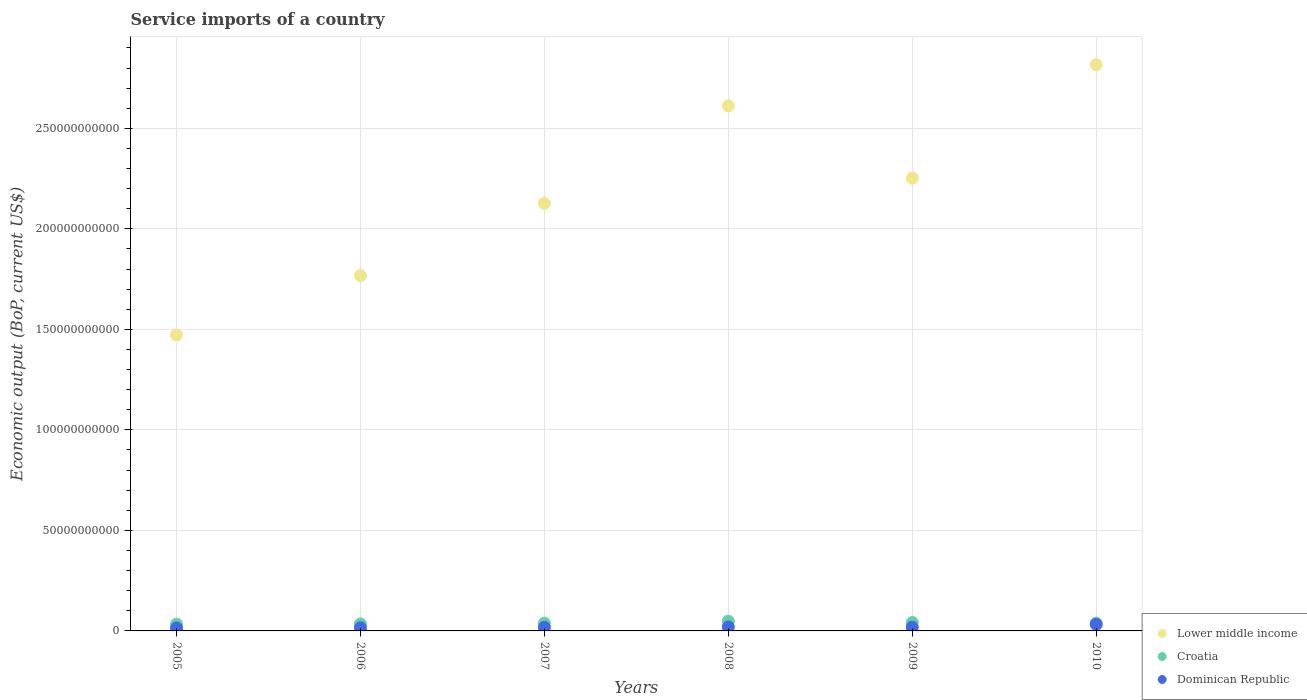How many different coloured dotlines are there?
Provide a succinct answer. 3. Is the number of dotlines equal to the number of legend labels?
Provide a succinct answer. Yes. What is the service imports in Lower middle income in 2007?
Provide a succinct answer. 2.13e+11. Across all years, what is the maximum service imports in Dominican Republic?
Your response must be concise. 3.29e+09. Across all years, what is the minimum service imports in Lower middle income?
Offer a very short reply. 1.47e+11. In which year was the service imports in Dominican Republic maximum?
Make the answer very short. 2010. What is the total service imports in Lower middle income in the graph?
Keep it short and to the point. 1.30e+12. What is the difference between the service imports in Dominican Republic in 2006 and that in 2008?
Offer a terse response. -4.07e+08. What is the difference between the service imports in Dominican Republic in 2007 and the service imports in Croatia in 2009?
Your answer should be very brief. -2.41e+09. What is the average service imports in Croatia per year?
Give a very brief answer. 3.93e+09. In the year 2005, what is the difference between the service imports in Dominican Republic and service imports in Lower middle income?
Your response must be concise. -1.46e+11. In how many years, is the service imports in Croatia greater than 90000000000 US$?
Make the answer very short. 0. What is the ratio of the service imports in Lower middle income in 2005 to that in 2009?
Offer a terse response. 0.65. Is the service imports in Dominican Republic in 2008 less than that in 2009?
Offer a terse response. No. Is the difference between the service imports in Dominican Republic in 2006 and 2010 greater than the difference between the service imports in Lower middle income in 2006 and 2010?
Provide a succinct answer. Yes. What is the difference between the highest and the second highest service imports in Dominican Republic?
Ensure brevity in your answer.  1.30e+09. What is the difference between the highest and the lowest service imports in Croatia?
Offer a very short reply. 1.46e+09. In how many years, is the service imports in Lower middle income greater than the average service imports in Lower middle income taken over all years?
Ensure brevity in your answer.  3. Does the service imports in Dominican Republic monotonically increase over the years?
Ensure brevity in your answer.  No. Is the service imports in Dominican Republic strictly greater than the service imports in Croatia over the years?
Make the answer very short. No. Is the service imports in Lower middle income strictly less than the service imports in Croatia over the years?
Your answer should be very brief. No. How many dotlines are there?
Provide a succinct answer. 3. How many years are there in the graph?
Make the answer very short. 6. What is the difference between two consecutive major ticks on the Y-axis?
Give a very brief answer. 5.00e+1. Are the values on the major ticks of Y-axis written in scientific E-notation?
Your answer should be very brief. No. Does the graph contain grids?
Offer a terse response. Yes. Where does the legend appear in the graph?
Keep it short and to the point. Bottom right. How many legend labels are there?
Give a very brief answer. 3. How are the legend labels stacked?
Your answer should be very brief. Vertical. What is the title of the graph?
Provide a succinct answer. Service imports of a country. Does "Libya" appear as one of the legend labels in the graph?
Your answer should be compact. No. What is the label or title of the Y-axis?
Provide a succinct answer. Economic output (BoP, current US$). What is the Economic output (BoP, current US$) of Lower middle income in 2005?
Ensure brevity in your answer.  1.47e+11. What is the Economic output (BoP, current US$) in Croatia in 2005?
Make the answer very short. 3.37e+09. What is the Economic output (BoP, current US$) of Dominican Republic in 2005?
Your answer should be very brief. 1.48e+09. What is the Economic output (BoP, current US$) of Lower middle income in 2006?
Offer a very short reply. 1.77e+11. What is the Economic output (BoP, current US$) of Croatia in 2006?
Offer a very short reply. 3.51e+09. What is the Economic output (BoP, current US$) of Dominican Republic in 2006?
Ensure brevity in your answer.  1.58e+09. What is the Economic output (BoP, current US$) of Lower middle income in 2007?
Provide a succinct answer. 2.13e+11. What is the Economic output (BoP, current US$) of Croatia in 2007?
Offer a terse response. 3.84e+09. What is the Economic output (BoP, current US$) in Dominican Republic in 2007?
Offer a very short reply. 1.77e+09. What is the Economic output (BoP, current US$) of Lower middle income in 2008?
Offer a terse response. 2.61e+11. What is the Economic output (BoP, current US$) in Croatia in 2008?
Ensure brevity in your answer.  4.83e+09. What is the Economic output (BoP, current US$) in Dominican Republic in 2008?
Make the answer very short. 1.99e+09. What is the Economic output (BoP, current US$) of Lower middle income in 2009?
Give a very brief answer. 2.25e+11. What is the Economic output (BoP, current US$) of Croatia in 2009?
Provide a short and direct response. 4.18e+09. What is the Economic output (BoP, current US$) in Dominican Republic in 2009?
Make the answer very short. 1.86e+09. What is the Economic output (BoP, current US$) in Lower middle income in 2010?
Ensure brevity in your answer.  2.82e+11. What is the Economic output (BoP, current US$) in Croatia in 2010?
Offer a terse response. 3.86e+09. What is the Economic output (BoP, current US$) in Dominican Republic in 2010?
Offer a terse response. 3.29e+09. Across all years, what is the maximum Economic output (BoP, current US$) of Lower middle income?
Your response must be concise. 2.82e+11. Across all years, what is the maximum Economic output (BoP, current US$) in Croatia?
Keep it short and to the point. 4.83e+09. Across all years, what is the maximum Economic output (BoP, current US$) in Dominican Republic?
Your response must be concise. 3.29e+09. Across all years, what is the minimum Economic output (BoP, current US$) in Lower middle income?
Your answer should be compact. 1.47e+11. Across all years, what is the minimum Economic output (BoP, current US$) in Croatia?
Your response must be concise. 3.37e+09. Across all years, what is the minimum Economic output (BoP, current US$) of Dominican Republic?
Offer a terse response. 1.48e+09. What is the total Economic output (BoP, current US$) in Lower middle income in the graph?
Provide a short and direct response. 1.30e+12. What is the total Economic output (BoP, current US$) of Croatia in the graph?
Your answer should be very brief. 2.36e+1. What is the total Economic output (BoP, current US$) of Dominican Republic in the graph?
Your answer should be compact. 1.20e+1. What is the difference between the Economic output (BoP, current US$) of Lower middle income in 2005 and that in 2006?
Your answer should be very brief. -2.95e+1. What is the difference between the Economic output (BoP, current US$) of Croatia in 2005 and that in 2006?
Your answer should be very brief. -1.38e+08. What is the difference between the Economic output (BoP, current US$) of Dominican Republic in 2005 and that in 2006?
Ensure brevity in your answer.  -1.04e+08. What is the difference between the Economic output (BoP, current US$) in Lower middle income in 2005 and that in 2007?
Provide a short and direct response. -6.55e+1. What is the difference between the Economic output (BoP, current US$) in Croatia in 2005 and that in 2007?
Give a very brief answer. -4.76e+08. What is the difference between the Economic output (BoP, current US$) in Dominican Republic in 2005 and that in 2007?
Give a very brief answer. -2.94e+08. What is the difference between the Economic output (BoP, current US$) in Lower middle income in 2005 and that in 2008?
Provide a succinct answer. -1.14e+11. What is the difference between the Economic output (BoP, current US$) of Croatia in 2005 and that in 2008?
Your answer should be very brief. -1.46e+09. What is the difference between the Economic output (BoP, current US$) of Dominican Republic in 2005 and that in 2008?
Your answer should be very brief. -5.11e+08. What is the difference between the Economic output (BoP, current US$) of Lower middle income in 2005 and that in 2009?
Give a very brief answer. -7.81e+1. What is the difference between the Economic output (BoP, current US$) in Croatia in 2005 and that in 2009?
Keep it short and to the point. -8.15e+08. What is the difference between the Economic output (BoP, current US$) of Dominican Republic in 2005 and that in 2009?
Your answer should be very brief. -3.79e+08. What is the difference between the Economic output (BoP, current US$) in Lower middle income in 2005 and that in 2010?
Offer a terse response. -1.34e+11. What is the difference between the Economic output (BoP, current US$) of Croatia in 2005 and that in 2010?
Provide a succinct answer. -4.94e+08. What is the difference between the Economic output (BoP, current US$) of Dominican Republic in 2005 and that in 2010?
Offer a very short reply. -1.81e+09. What is the difference between the Economic output (BoP, current US$) of Lower middle income in 2006 and that in 2007?
Keep it short and to the point. -3.59e+1. What is the difference between the Economic output (BoP, current US$) in Croatia in 2006 and that in 2007?
Provide a succinct answer. -3.38e+08. What is the difference between the Economic output (BoP, current US$) of Dominican Republic in 2006 and that in 2007?
Provide a short and direct response. -1.90e+08. What is the difference between the Economic output (BoP, current US$) of Lower middle income in 2006 and that in 2008?
Make the answer very short. -8.44e+1. What is the difference between the Economic output (BoP, current US$) in Croatia in 2006 and that in 2008?
Make the answer very short. -1.32e+09. What is the difference between the Economic output (BoP, current US$) in Dominican Republic in 2006 and that in 2008?
Your response must be concise. -4.07e+08. What is the difference between the Economic output (BoP, current US$) in Lower middle income in 2006 and that in 2009?
Offer a terse response. -4.85e+1. What is the difference between the Economic output (BoP, current US$) of Croatia in 2006 and that in 2009?
Your answer should be very brief. -6.77e+08. What is the difference between the Economic output (BoP, current US$) of Dominican Republic in 2006 and that in 2009?
Give a very brief answer. -2.75e+08. What is the difference between the Economic output (BoP, current US$) in Lower middle income in 2006 and that in 2010?
Offer a terse response. -1.05e+11. What is the difference between the Economic output (BoP, current US$) in Croatia in 2006 and that in 2010?
Your answer should be compact. -3.56e+08. What is the difference between the Economic output (BoP, current US$) in Dominican Republic in 2006 and that in 2010?
Provide a short and direct response. -1.70e+09. What is the difference between the Economic output (BoP, current US$) of Lower middle income in 2007 and that in 2008?
Your response must be concise. -4.85e+1. What is the difference between the Economic output (BoP, current US$) of Croatia in 2007 and that in 2008?
Provide a short and direct response. -9.87e+08. What is the difference between the Economic output (BoP, current US$) in Dominican Republic in 2007 and that in 2008?
Provide a short and direct response. -2.17e+08. What is the difference between the Economic output (BoP, current US$) in Lower middle income in 2007 and that in 2009?
Provide a succinct answer. -1.26e+1. What is the difference between the Economic output (BoP, current US$) of Croatia in 2007 and that in 2009?
Provide a short and direct response. -3.39e+08. What is the difference between the Economic output (BoP, current US$) of Dominican Republic in 2007 and that in 2009?
Give a very brief answer. -8.46e+07. What is the difference between the Economic output (BoP, current US$) of Lower middle income in 2007 and that in 2010?
Your answer should be compact. -6.90e+1. What is the difference between the Economic output (BoP, current US$) in Croatia in 2007 and that in 2010?
Provide a short and direct response. -1.77e+07. What is the difference between the Economic output (BoP, current US$) of Dominican Republic in 2007 and that in 2010?
Provide a succinct answer. -1.51e+09. What is the difference between the Economic output (BoP, current US$) in Lower middle income in 2008 and that in 2009?
Your answer should be very brief. 3.59e+1. What is the difference between the Economic output (BoP, current US$) in Croatia in 2008 and that in 2009?
Keep it short and to the point. 6.48e+08. What is the difference between the Economic output (BoP, current US$) in Dominican Republic in 2008 and that in 2009?
Give a very brief answer. 1.32e+08. What is the difference between the Economic output (BoP, current US$) of Lower middle income in 2008 and that in 2010?
Your answer should be compact. -2.05e+1. What is the difference between the Economic output (BoP, current US$) in Croatia in 2008 and that in 2010?
Your answer should be very brief. 9.69e+08. What is the difference between the Economic output (BoP, current US$) in Dominican Republic in 2008 and that in 2010?
Your answer should be very brief. -1.30e+09. What is the difference between the Economic output (BoP, current US$) of Lower middle income in 2009 and that in 2010?
Offer a very short reply. -5.64e+1. What is the difference between the Economic output (BoP, current US$) of Croatia in 2009 and that in 2010?
Offer a very short reply. 3.21e+08. What is the difference between the Economic output (BoP, current US$) in Dominican Republic in 2009 and that in 2010?
Provide a short and direct response. -1.43e+09. What is the difference between the Economic output (BoP, current US$) in Lower middle income in 2005 and the Economic output (BoP, current US$) in Croatia in 2006?
Offer a very short reply. 1.44e+11. What is the difference between the Economic output (BoP, current US$) of Lower middle income in 2005 and the Economic output (BoP, current US$) of Dominican Republic in 2006?
Give a very brief answer. 1.46e+11. What is the difference between the Economic output (BoP, current US$) in Croatia in 2005 and the Economic output (BoP, current US$) in Dominican Republic in 2006?
Make the answer very short. 1.79e+09. What is the difference between the Economic output (BoP, current US$) of Lower middle income in 2005 and the Economic output (BoP, current US$) of Croatia in 2007?
Your response must be concise. 1.43e+11. What is the difference between the Economic output (BoP, current US$) of Lower middle income in 2005 and the Economic output (BoP, current US$) of Dominican Republic in 2007?
Offer a terse response. 1.45e+11. What is the difference between the Economic output (BoP, current US$) in Croatia in 2005 and the Economic output (BoP, current US$) in Dominican Republic in 2007?
Provide a short and direct response. 1.60e+09. What is the difference between the Economic output (BoP, current US$) of Lower middle income in 2005 and the Economic output (BoP, current US$) of Croatia in 2008?
Ensure brevity in your answer.  1.42e+11. What is the difference between the Economic output (BoP, current US$) in Lower middle income in 2005 and the Economic output (BoP, current US$) in Dominican Republic in 2008?
Provide a short and direct response. 1.45e+11. What is the difference between the Economic output (BoP, current US$) in Croatia in 2005 and the Economic output (BoP, current US$) in Dominican Republic in 2008?
Make the answer very short. 1.38e+09. What is the difference between the Economic output (BoP, current US$) of Lower middle income in 2005 and the Economic output (BoP, current US$) of Croatia in 2009?
Ensure brevity in your answer.  1.43e+11. What is the difference between the Economic output (BoP, current US$) of Lower middle income in 2005 and the Economic output (BoP, current US$) of Dominican Republic in 2009?
Provide a succinct answer. 1.45e+11. What is the difference between the Economic output (BoP, current US$) of Croatia in 2005 and the Economic output (BoP, current US$) of Dominican Republic in 2009?
Offer a very short reply. 1.51e+09. What is the difference between the Economic output (BoP, current US$) of Lower middle income in 2005 and the Economic output (BoP, current US$) of Croatia in 2010?
Your answer should be very brief. 1.43e+11. What is the difference between the Economic output (BoP, current US$) of Lower middle income in 2005 and the Economic output (BoP, current US$) of Dominican Republic in 2010?
Your response must be concise. 1.44e+11. What is the difference between the Economic output (BoP, current US$) in Croatia in 2005 and the Economic output (BoP, current US$) in Dominican Republic in 2010?
Offer a very short reply. 8.13e+07. What is the difference between the Economic output (BoP, current US$) in Lower middle income in 2006 and the Economic output (BoP, current US$) in Croatia in 2007?
Keep it short and to the point. 1.73e+11. What is the difference between the Economic output (BoP, current US$) in Lower middle income in 2006 and the Economic output (BoP, current US$) in Dominican Republic in 2007?
Ensure brevity in your answer.  1.75e+11. What is the difference between the Economic output (BoP, current US$) in Croatia in 2006 and the Economic output (BoP, current US$) in Dominican Republic in 2007?
Keep it short and to the point. 1.73e+09. What is the difference between the Economic output (BoP, current US$) in Lower middle income in 2006 and the Economic output (BoP, current US$) in Croatia in 2008?
Offer a very short reply. 1.72e+11. What is the difference between the Economic output (BoP, current US$) of Lower middle income in 2006 and the Economic output (BoP, current US$) of Dominican Republic in 2008?
Your response must be concise. 1.75e+11. What is the difference between the Economic output (BoP, current US$) in Croatia in 2006 and the Economic output (BoP, current US$) in Dominican Republic in 2008?
Provide a succinct answer. 1.52e+09. What is the difference between the Economic output (BoP, current US$) of Lower middle income in 2006 and the Economic output (BoP, current US$) of Croatia in 2009?
Offer a terse response. 1.73e+11. What is the difference between the Economic output (BoP, current US$) of Lower middle income in 2006 and the Economic output (BoP, current US$) of Dominican Republic in 2009?
Keep it short and to the point. 1.75e+11. What is the difference between the Economic output (BoP, current US$) in Croatia in 2006 and the Economic output (BoP, current US$) in Dominican Republic in 2009?
Your response must be concise. 1.65e+09. What is the difference between the Economic output (BoP, current US$) in Lower middle income in 2006 and the Economic output (BoP, current US$) in Croatia in 2010?
Offer a terse response. 1.73e+11. What is the difference between the Economic output (BoP, current US$) of Lower middle income in 2006 and the Economic output (BoP, current US$) of Dominican Republic in 2010?
Provide a succinct answer. 1.73e+11. What is the difference between the Economic output (BoP, current US$) in Croatia in 2006 and the Economic output (BoP, current US$) in Dominican Republic in 2010?
Provide a short and direct response. 2.19e+08. What is the difference between the Economic output (BoP, current US$) in Lower middle income in 2007 and the Economic output (BoP, current US$) in Croatia in 2008?
Provide a short and direct response. 2.08e+11. What is the difference between the Economic output (BoP, current US$) in Lower middle income in 2007 and the Economic output (BoP, current US$) in Dominican Republic in 2008?
Your response must be concise. 2.11e+11. What is the difference between the Economic output (BoP, current US$) of Croatia in 2007 and the Economic output (BoP, current US$) of Dominican Republic in 2008?
Provide a succinct answer. 1.85e+09. What is the difference between the Economic output (BoP, current US$) of Lower middle income in 2007 and the Economic output (BoP, current US$) of Croatia in 2009?
Provide a succinct answer. 2.08e+11. What is the difference between the Economic output (BoP, current US$) in Lower middle income in 2007 and the Economic output (BoP, current US$) in Dominican Republic in 2009?
Offer a terse response. 2.11e+11. What is the difference between the Economic output (BoP, current US$) in Croatia in 2007 and the Economic output (BoP, current US$) in Dominican Republic in 2009?
Keep it short and to the point. 1.99e+09. What is the difference between the Economic output (BoP, current US$) of Lower middle income in 2007 and the Economic output (BoP, current US$) of Croatia in 2010?
Your answer should be very brief. 2.09e+11. What is the difference between the Economic output (BoP, current US$) of Lower middle income in 2007 and the Economic output (BoP, current US$) of Dominican Republic in 2010?
Your answer should be compact. 2.09e+11. What is the difference between the Economic output (BoP, current US$) in Croatia in 2007 and the Economic output (BoP, current US$) in Dominican Republic in 2010?
Provide a succinct answer. 5.57e+08. What is the difference between the Economic output (BoP, current US$) of Lower middle income in 2008 and the Economic output (BoP, current US$) of Croatia in 2009?
Give a very brief answer. 2.57e+11. What is the difference between the Economic output (BoP, current US$) in Lower middle income in 2008 and the Economic output (BoP, current US$) in Dominican Republic in 2009?
Keep it short and to the point. 2.59e+11. What is the difference between the Economic output (BoP, current US$) in Croatia in 2008 and the Economic output (BoP, current US$) in Dominican Republic in 2009?
Offer a very short reply. 2.97e+09. What is the difference between the Economic output (BoP, current US$) of Lower middle income in 2008 and the Economic output (BoP, current US$) of Croatia in 2010?
Ensure brevity in your answer.  2.57e+11. What is the difference between the Economic output (BoP, current US$) in Lower middle income in 2008 and the Economic output (BoP, current US$) in Dominican Republic in 2010?
Offer a very short reply. 2.58e+11. What is the difference between the Economic output (BoP, current US$) of Croatia in 2008 and the Economic output (BoP, current US$) of Dominican Republic in 2010?
Ensure brevity in your answer.  1.54e+09. What is the difference between the Economic output (BoP, current US$) of Lower middle income in 2009 and the Economic output (BoP, current US$) of Croatia in 2010?
Make the answer very short. 2.21e+11. What is the difference between the Economic output (BoP, current US$) of Lower middle income in 2009 and the Economic output (BoP, current US$) of Dominican Republic in 2010?
Your answer should be compact. 2.22e+11. What is the difference between the Economic output (BoP, current US$) in Croatia in 2009 and the Economic output (BoP, current US$) in Dominican Republic in 2010?
Your answer should be very brief. 8.96e+08. What is the average Economic output (BoP, current US$) of Lower middle income per year?
Make the answer very short. 2.17e+11. What is the average Economic output (BoP, current US$) of Croatia per year?
Ensure brevity in your answer.  3.93e+09. What is the average Economic output (BoP, current US$) in Dominican Republic per year?
Ensure brevity in your answer.  1.99e+09. In the year 2005, what is the difference between the Economic output (BoP, current US$) in Lower middle income and Economic output (BoP, current US$) in Croatia?
Offer a terse response. 1.44e+11. In the year 2005, what is the difference between the Economic output (BoP, current US$) of Lower middle income and Economic output (BoP, current US$) of Dominican Republic?
Offer a terse response. 1.46e+11. In the year 2005, what is the difference between the Economic output (BoP, current US$) of Croatia and Economic output (BoP, current US$) of Dominican Republic?
Your answer should be very brief. 1.89e+09. In the year 2006, what is the difference between the Economic output (BoP, current US$) of Lower middle income and Economic output (BoP, current US$) of Croatia?
Provide a succinct answer. 1.73e+11. In the year 2006, what is the difference between the Economic output (BoP, current US$) in Lower middle income and Economic output (BoP, current US$) in Dominican Republic?
Ensure brevity in your answer.  1.75e+11. In the year 2006, what is the difference between the Economic output (BoP, current US$) in Croatia and Economic output (BoP, current US$) in Dominican Republic?
Provide a short and direct response. 1.92e+09. In the year 2007, what is the difference between the Economic output (BoP, current US$) of Lower middle income and Economic output (BoP, current US$) of Croatia?
Provide a short and direct response. 2.09e+11. In the year 2007, what is the difference between the Economic output (BoP, current US$) in Lower middle income and Economic output (BoP, current US$) in Dominican Republic?
Make the answer very short. 2.11e+11. In the year 2007, what is the difference between the Economic output (BoP, current US$) of Croatia and Economic output (BoP, current US$) of Dominican Republic?
Your response must be concise. 2.07e+09. In the year 2008, what is the difference between the Economic output (BoP, current US$) in Lower middle income and Economic output (BoP, current US$) in Croatia?
Your answer should be very brief. 2.56e+11. In the year 2008, what is the difference between the Economic output (BoP, current US$) in Lower middle income and Economic output (BoP, current US$) in Dominican Republic?
Offer a terse response. 2.59e+11. In the year 2008, what is the difference between the Economic output (BoP, current US$) in Croatia and Economic output (BoP, current US$) in Dominican Republic?
Your answer should be compact. 2.84e+09. In the year 2009, what is the difference between the Economic output (BoP, current US$) in Lower middle income and Economic output (BoP, current US$) in Croatia?
Your answer should be compact. 2.21e+11. In the year 2009, what is the difference between the Economic output (BoP, current US$) of Lower middle income and Economic output (BoP, current US$) of Dominican Republic?
Offer a terse response. 2.23e+11. In the year 2009, what is the difference between the Economic output (BoP, current US$) of Croatia and Economic output (BoP, current US$) of Dominican Republic?
Offer a very short reply. 2.33e+09. In the year 2010, what is the difference between the Economic output (BoP, current US$) in Lower middle income and Economic output (BoP, current US$) in Croatia?
Provide a short and direct response. 2.78e+11. In the year 2010, what is the difference between the Economic output (BoP, current US$) in Lower middle income and Economic output (BoP, current US$) in Dominican Republic?
Offer a terse response. 2.78e+11. In the year 2010, what is the difference between the Economic output (BoP, current US$) in Croatia and Economic output (BoP, current US$) in Dominican Republic?
Your response must be concise. 5.75e+08. What is the ratio of the Economic output (BoP, current US$) in Lower middle income in 2005 to that in 2006?
Ensure brevity in your answer.  0.83. What is the ratio of the Economic output (BoP, current US$) of Croatia in 2005 to that in 2006?
Your answer should be very brief. 0.96. What is the ratio of the Economic output (BoP, current US$) of Dominican Republic in 2005 to that in 2006?
Your response must be concise. 0.93. What is the ratio of the Economic output (BoP, current US$) of Lower middle income in 2005 to that in 2007?
Give a very brief answer. 0.69. What is the ratio of the Economic output (BoP, current US$) in Croatia in 2005 to that in 2007?
Offer a very short reply. 0.88. What is the ratio of the Economic output (BoP, current US$) in Dominican Republic in 2005 to that in 2007?
Provide a short and direct response. 0.83. What is the ratio of the Economic output (BoP, current US$) of Lower middle income in 2005 to that in 2008?
Provide a succinct answer. 0.56. What is the ratio of the Economic output (BoP, current US$) of Croatia in 2005 to that in 2008?
Make the answer very short. 0.7. What is the ratio of the Economic output (BoP, current US$) in Dominican Republic in 2005 to that in 2008?
Keep it short and to the point. 0.74. What is the ratio of the Economic output (BoP, current US$) in Lower middle income in 2005 to that in 2009?
Ensure brevity in your answer.  0.65. What is the ratio of the Economic output (BoP, current US$) in Croatia in 2005 to that in 2009?
Your answer should be compact. 0.81. What is the ratio of the Economic output (BoP, current US$) in Dominican Republic in 2005 to that in 2009?
Your answer should be very brief. 0.8. What is the ratio of the Economic output (BoP, current US$) of Lower middle income in 2005 to that in 2010?
Provide a succinct answer. 0.52. What is the ratio of the Economic output (BoP, current US$) of Croatia in 2005 to that in 2010?
Your answer should be compact. 0.87. What is the ratio of the Economic output (BoP, current US$) of Dominican Republic in 2005 to that in 2010?
Make the answer very short. 0.45. What is the ratio of the Economic output (BoP, current US$) in Lower middle income in 2006 to that in 2007?
Make the answer very short. 0.83. What is the ratio of the Economic output (BoP, current US$) of Croatia in 2006 to that in 2007?
Provide a succinct answer. 0.91. What is the ratio of the Economic output (BoP, current US$) of Dominican Republic in 2006 to that in 2007?
Offer a very short reply. 0.89. What is the ratio of the Economic output (BoP, current US$) of Lower middle income in 2006 to that in 2008?
Give a very brief answer. 0.68. What is the ratio of the Economic output (BoP, current US$) of Croatia in 2006 to that in 2008?
Give a very brief answer. 0.73. What is the ratio of the Economic output (BoP, current US$) of Dominican Republic in 2006 to that in 2008?
Give a very brief answer. 0.8. What is the ratio of the Economic output (BoP, current US$) of Lower middle income in 2006 to that in 2009?
Make the answer very short. 0.78. What is the ratio of the Economic output (BoP, current US$) in Croatia in 2006 to that in 2009?
Your answer should be very brief. 0.84. What is the ratio of the Economic output (BoP, current US$) of Dominican Republic in 2006 to that in 2009?
Offer a very short reply. 0.85. What is the ratio of the Economic output (BoP, current US$) of Lower middle income in 2006 to that in 2010?
Offer a terse response. 0.63. What is the ratio of the Economic output (BoP, current US$) of Croatia in 2006 to that in 2010?
Provide a succinct answer. 0.91. What is the ratio of the Economic output (BoP, current US$) in Dominican Republic in 2006 to that in 2010?
Your response must be concise. 0.48. What is the ratio of the Economic output (BoP, current US$) in Lower middle income in 2007 to that in 2008?
Offer a terse response. 0.81. What is the ratio of the Economic output (BoP, current US$) in Croatia in 2007 to that in 2008?
Your answer should be very brief. 0.8. What is the ratio of the Economic output (BoP, current US$) of Dominican Republic in 2007 to that in 2008?
Keep it short and to the point. 0.89. What is the ratio of the Economic output (BoP, current US$) of Lower middle income in 2007 to that in 2009?
Ensure brevity in your answer.  0.94. What is the ratio of the Economic output (BoP, current US$) of Croatia in 2007 to that in 2009?
Give a very brief answer. 0.92. What is the ratio of the Economic output (BoP, current US$) in Dominican Republic in 2007 to that in 2009?
Offer a terse response. 0.95. What is the ratio of the Economic output (BoP, current US$) in Lower middle income in 2007 to that in 2010?
Make the answer very short. 0.76. What is the ratio of the Economic output (BoP, current US$) in Croatia in 2007 to that in 2010?
Make the answer very short. 1. What is the ratio of the Economic output (BoP, current US$) in Dominican Republic in 2007 to that in 2010?
Your response must be concise. 0.54. What is the ratio of the Economic output (BoP, current US$) of Lower middle income in 2008 to that in 2009?
Your answer should be very brief. 1.16. What is the ratio of the Economic output (BoP, current US$) in Croatia in 2008 to that in 2009?
Your answer should be very brief. 1.15. What is the ratio of the Economic output (BoP, current US$) in Dominican Republic in 2008 to that in 2009?
Your answer should be very brief. 1.07. What is the ratio of the Economic output (BoP, current US$) in Lower middle income in 2008 to that in 2010?
Your answer should be compact. 0.93. What is the ratio of the Economic output (BoP, current US$) in Croatia in 2008 to that in 2010?
Offer a terse response. 1.25. What is the ratio of the Economic output (BoP, current US$) in Dominican Republic in 2008 to that in 2010?
Give a very brief answer. 0.61. What is the ratio of the Economic output (BoP, current US$) of Lower middle income in 2009 to that in 2010?
Keep it short and to the point. 0.8. What is the ratio of the Economic output (BoP, current US$) of Croatia in 2009 to that in 2010?
Make the answer very short. 1.08. What is the ratio of the Economic output (BoP, current US$) in Dominican Republic in 2009 to that in 2010?
Your response must be concise. 0.56. What is the difference between the highest and the second highest Economic output (BoP, current US$) in Lower middle income?
Keep it short and to the point. 2.05e+1. What is the difference between the highest and the second highest Economic output (BoP, current US$) of Croatia?
Provide a short and direct response. 6.48e+08. What is the difference between the highest and the second highest Economic output (BoP, current US$) in Dominican Republic?
Make the answer very short. 1.30e+09. What is the difference between the highest and the lowest Economic output (BoP, current US$) in Lower middle income?
Offer a very short reply. 1.34e+11. What is the difference between the highest and the lowest Economic output (BoP, current US$) in Croatia?
Your answer should be compact. 1.46e+09. What is the difference between the highest and the lowest Economic output (BoP, current US$) of Dominican Republic?
Offer a terse response. 1.81e+09. 